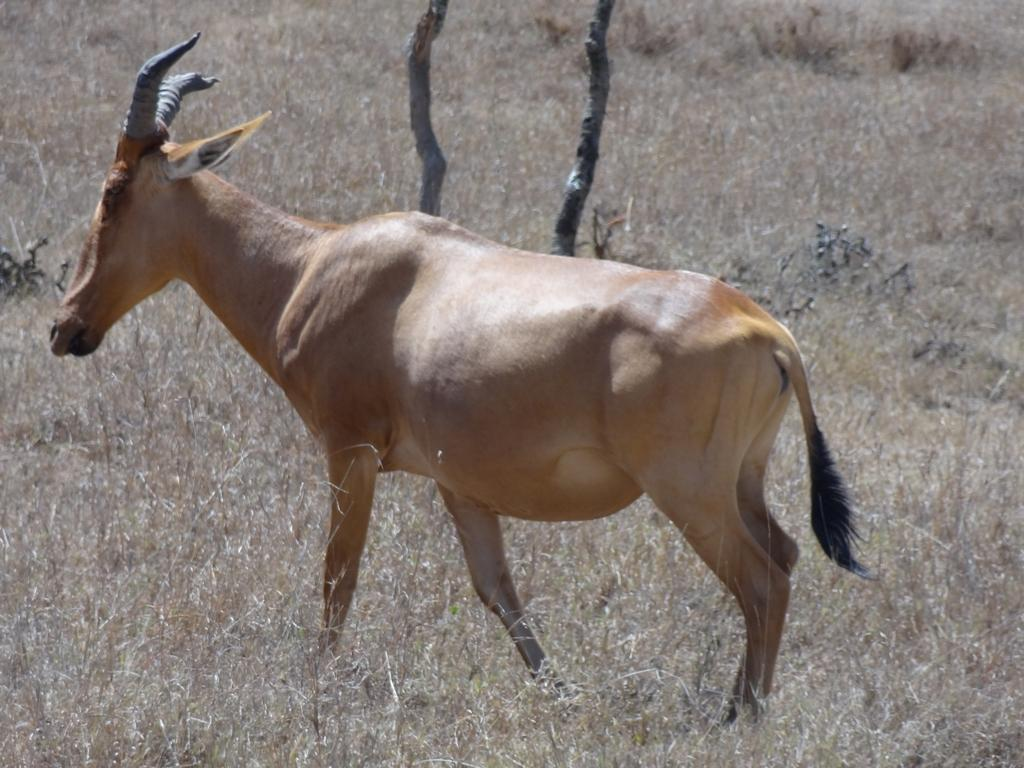What type of animal is in the picture? There is an animal in the picture, but the specific type cannot be determined from the provided facts. What is the ground like around the animal? There is dry grass around the animal. What can be seen behind the animal? There are two dry trees behind the animal. What type of sugar is being used for the animal's dinner in the image? There is no sugar or dinner present in the image, as it only features an animal, dry grass, and two dry trees. 